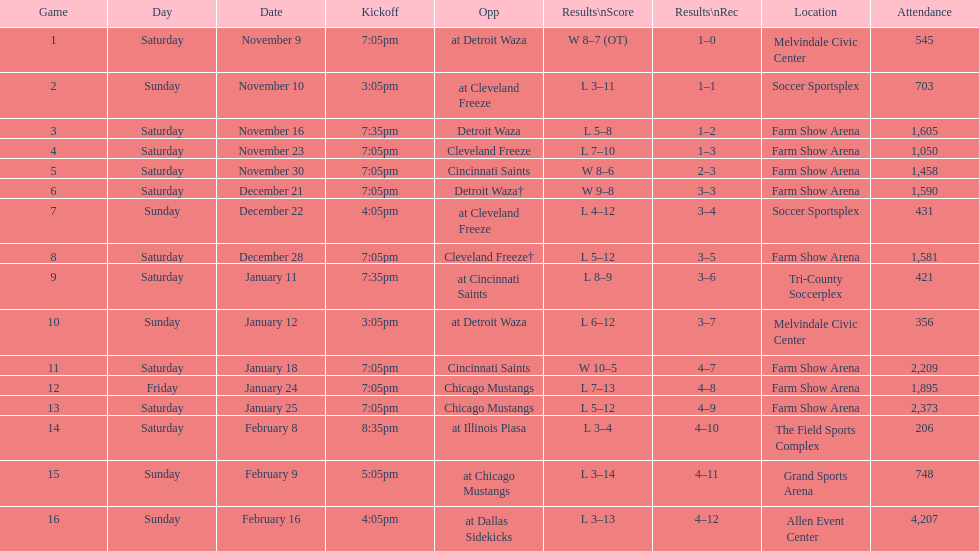How many times did the team play at home but did not win? 5. 